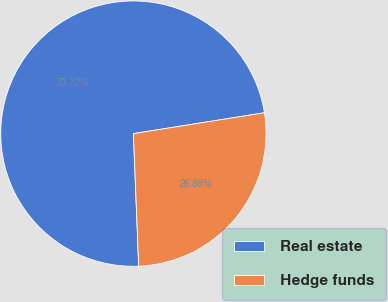<chart> <loc_0><loc_0><loc_500><loc_500><pie_chart><fcel>Real estate<fcel>Hedge funds<nl><fcel>73.12%<fcel>26.88%<nl></chart> 